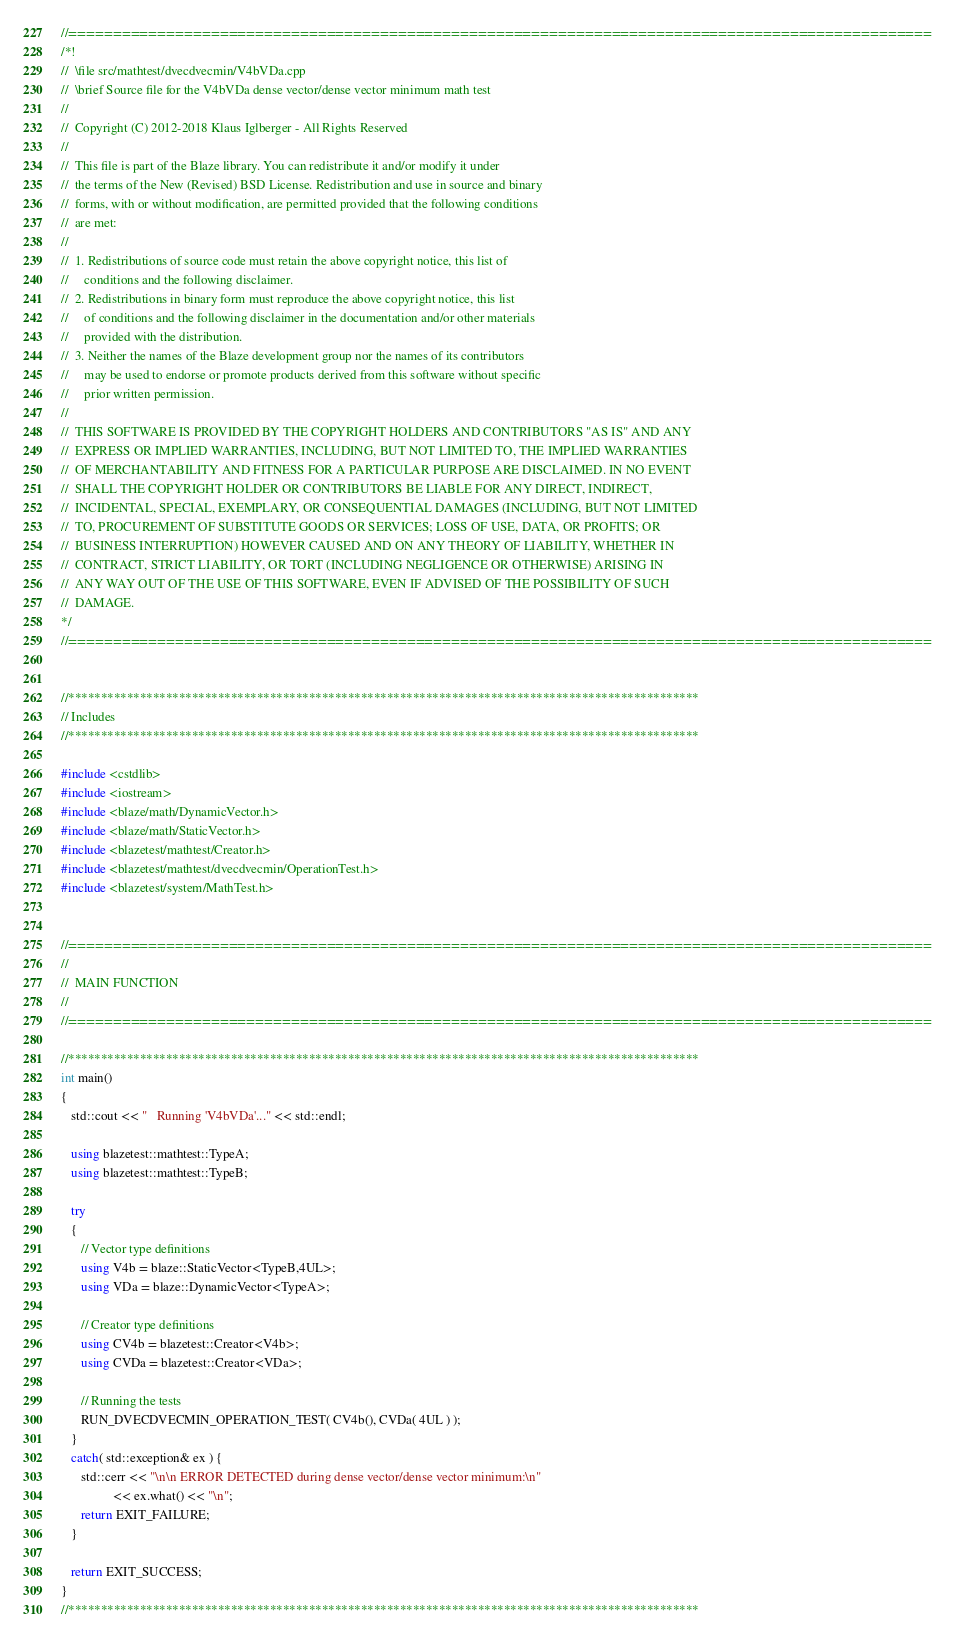<code> <loc_0><loc_0><loc_500><loc_500><_C++_>//=================================================================================================
/*!
//  \file src/mathtest/dvecdvecmin/V4bVDa.cpp
//  \brief Source file for the V4bVDa dense vector/dense vector minimum math test
//
//  Copyright (C) 2012-2018 Klaus Iglberger - All Rights Reserved
//
//  This file is part of the Blaze library. You can redistribute it and/or modify it under
//  the terms of the New (Revised) BSD License. Redistribution and use in source and binary
//  forms, with or without modification, are permitted provided that the following conditions
//  are met:
//
//  1. Redistributions of source code must retain the above copyright notice, this list of
//     conditions and the following disclaimer.
//  2. Redistributions in binary form must reproduce the above copyright notice, this list
//     of conditions and the following disclaimer in the documentation and/or other materials
//     provided with the distribution.
//  3. Neither the names of the Blaze development group nor the names of its contributors
//     may be used to endorse or promote products derived from this software without specific
//     prior written permission.
//
//  THIS SOFTWARE IS PROVIDED BY THE COPYRIGHT HOLDERS AND CONTRIBUTORS "AS IS" AND ANY
//  EXPRESS OR IMPLIED WARRANTIES, INCLUDING, BUT NOT LIMITED TO, THE IMPLIED WARRANTIES
//  OF MERCHANTABILITY AND FITNESS FOR A PARTICULAR PURPOSE ARE DISCLAIMED. IN NO EVENT
//  SHALL THE COPYRIGHT HOLDER OR CONTRIBUTORS BE LIABLE FOR ANY DIRECT, INDIRECT,
//  INCIDENTAL, SPECIAL, EXEMPLARY, OR CONSEQUENTIAL DAMAGES (INCLUDING, BUT NOT LIMITED
//  TO, PROCUREMENT OF SUBSTITUTE GOODS OR SERVICES; LOSS OF USE, DATA, OR PROFITS; OR
//  BUSINESS INTERRUPTION) HOWEVER CAUSED AND ON ANY THEORY OF LIABILITY, WHETHER IN
//  CONTRACT, STRICT LIABILITY, OR TORT (INCLUDING NEGLIGENCE OR OTHERWISE) ARISING IN
//  ANY WAY OUT OF THE USE OF THIS SOFTWARE, EVEN IF ADVISED OF THE POSSIBILITY OF SUCH
//  DAMAGE.
*/
//=================================================================================================


//*************************************************************************************************
// Includes
//*************************************************************************************************

#include <cstdlib>
#include <iostream>
#include <blaze/math/DynamicVector.h>
#include <blaze/math/StaticVector.h>
#include <blazetest/mathtest/Creator.h>
#include <blazetest/mathtest/dvecdvecmin/OperationTest.h>
#include <blazetest/system/MathTest.h>


//=================================================================================================
//
//  MAIN FUNCTION
//
//=================================================================================================

//*************************************************************************************************
int main()
{
   std::cout << "   Running 'V4bVDa'..." << std::endl;

   using blazetest::mathtest::TypeA;
   using blazetest::mathtest::TypeB;

   try
   {
      // Vector type definitions
      using V4b = blaze::StaticVector<TypeB,4UL>;
      using VDa = blaze::DynamicVector<TypeA>;

      // Creator type definitions
      using CV4b = blazetest::Creator<V4b>;
      using CVDa = blazetest::Creator<VDa>;

      // Running the tests
      RUN_DVECDVECMIN_OPERATION_TEST( CV4b(), CVDa( 4UL ) );
   }
   catch( std::exception& ex ) {
      std::cerr << "\n\n ERROR DETECTED during dense vector/dense vector minimum:\n"
                << ex.what() << "\n";
      return EXIT_FAILURE;
   }

   return EXIT_SUCCESS;
}
//*************************************************************************************************
</code> 